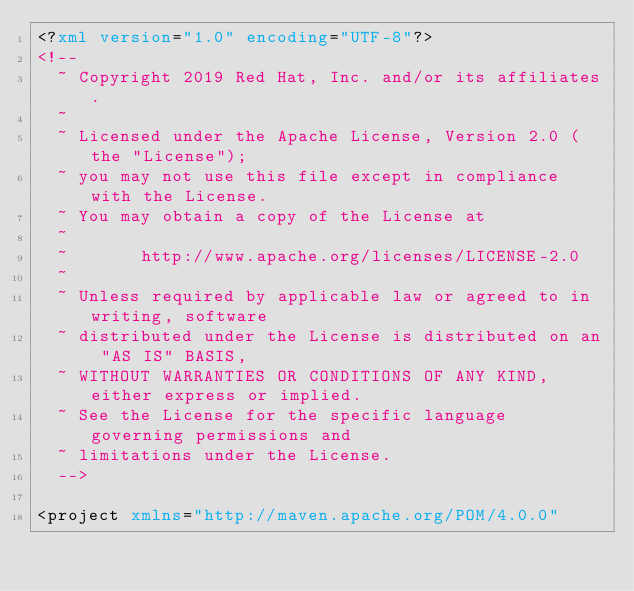<code> <loc_0><loc_0><loc_500><loc_500><_XML_><?xml version="1.0" encoding="UTF-8"?>
<!--
  ~ Copyright 2019 Red Hat, Inc. and/or its affiliates.
  ~
  ~ Licensed under the Apache License, Version 2.0 (the "License");
  ~ you may not use this file except in compliance with the License.
  ~ You may obtain a copy of the License at
  ~
  ~       http://www.apache.org/licenses/LICENSE-2.0
  ~
  ~ Unless required by applicable law or agreed to in writing, software
  ~ distributed under the License is distributed on an "AS IS" BASIS,
  ~ WITHOUT WARRANTIES OR CONDITIONS OF ANY KIND, either express or implied.
  ~ See the License for the specific language governing permissions and
  ~ limitations under the License.
  -->

<project xmlns="http://maven.apache.org/POM/4.0.0"</code> 